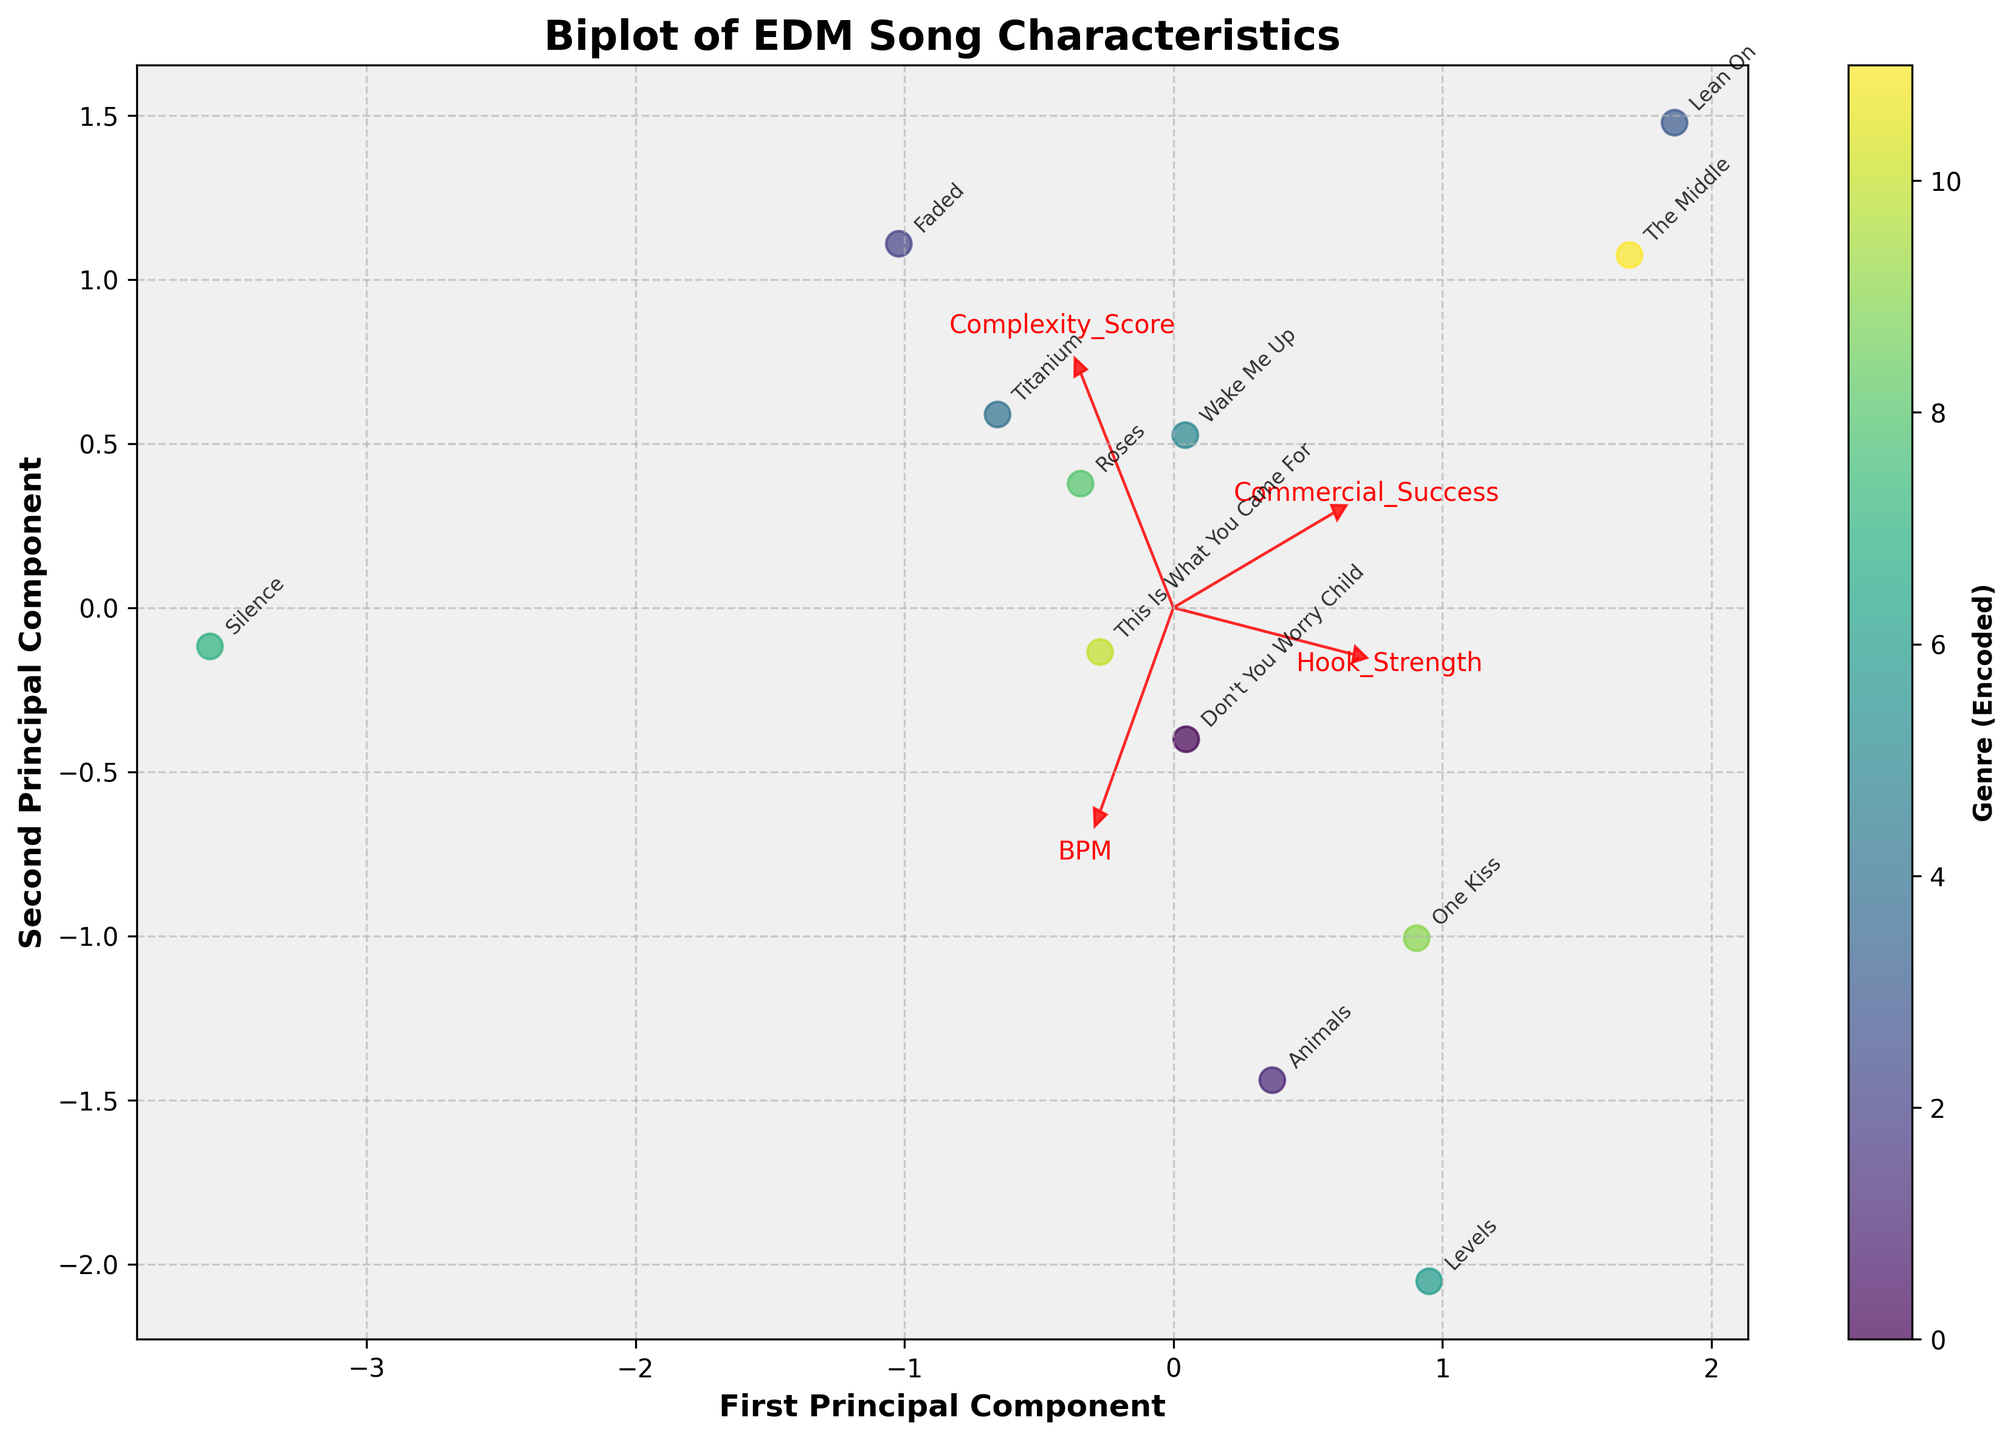What is the title of the figure? The figure title is usually located at the top of the plot. By observing the top of this plot, the title reads "Biplot of EDM Song Characteristics"
Answer: Biplot of EDM Song Characteristics How many principal components are represented in the figure? The x-axis and y-axis labels usually indicate the principal components. In this case, the labels say "First Principal Component" and "Second Principal Component"
Answer: Two Which feature has the longest vector in the biplot? We look at the arrows representing the feature vectors. The length of the arrow in the biplot typically shows the strength of the feature. By observing, "BPM" has the longest vector
Answer: BPM How many different colors (indicating genres) are shown in the biplot? By examining the scatterplot, the variation in the color palette can be counted. There are five different colors representing different genres
Answer: Five Which song has the highest value on the second principal component? We need to see which data point is placed highest on the y-axis (Second Principal Component) in the biplot. "Silence" is the song with the highest value on the second principal component
Answer: Silence What is the relationship between 'Hook Strength' and 'Commercial Success' based on their vectors? The direction and length of the vectors can indicate relationships. If vectors point similarly, they are positively correlated. 'Hook Strength' and 'Commercial Success' vectors point in almost the same direction, indicating a positive correlation
Answer: Positive correlation Which song is closest to the origin of the biplot? The origin of the biplot is where the x-axis and y-axis intersect. If we observe the points, “Animals” is the closest to this origin point
Answer: Animals Is there a genre with more concentration of songs in a specific area? By grouping songs of the same color, we can infer the concentration. The Progressive House genre (purple) seems to cluster more closely around a specific area.
Answer: Progressive House Do both principal components explain all the variance in the original data? We need to refer to the biplot and check the feature vectors' spread and the coverage area. Since PCA typically uses all components to show variance, it's unlikely to explain all variance with two components
Answer: No 